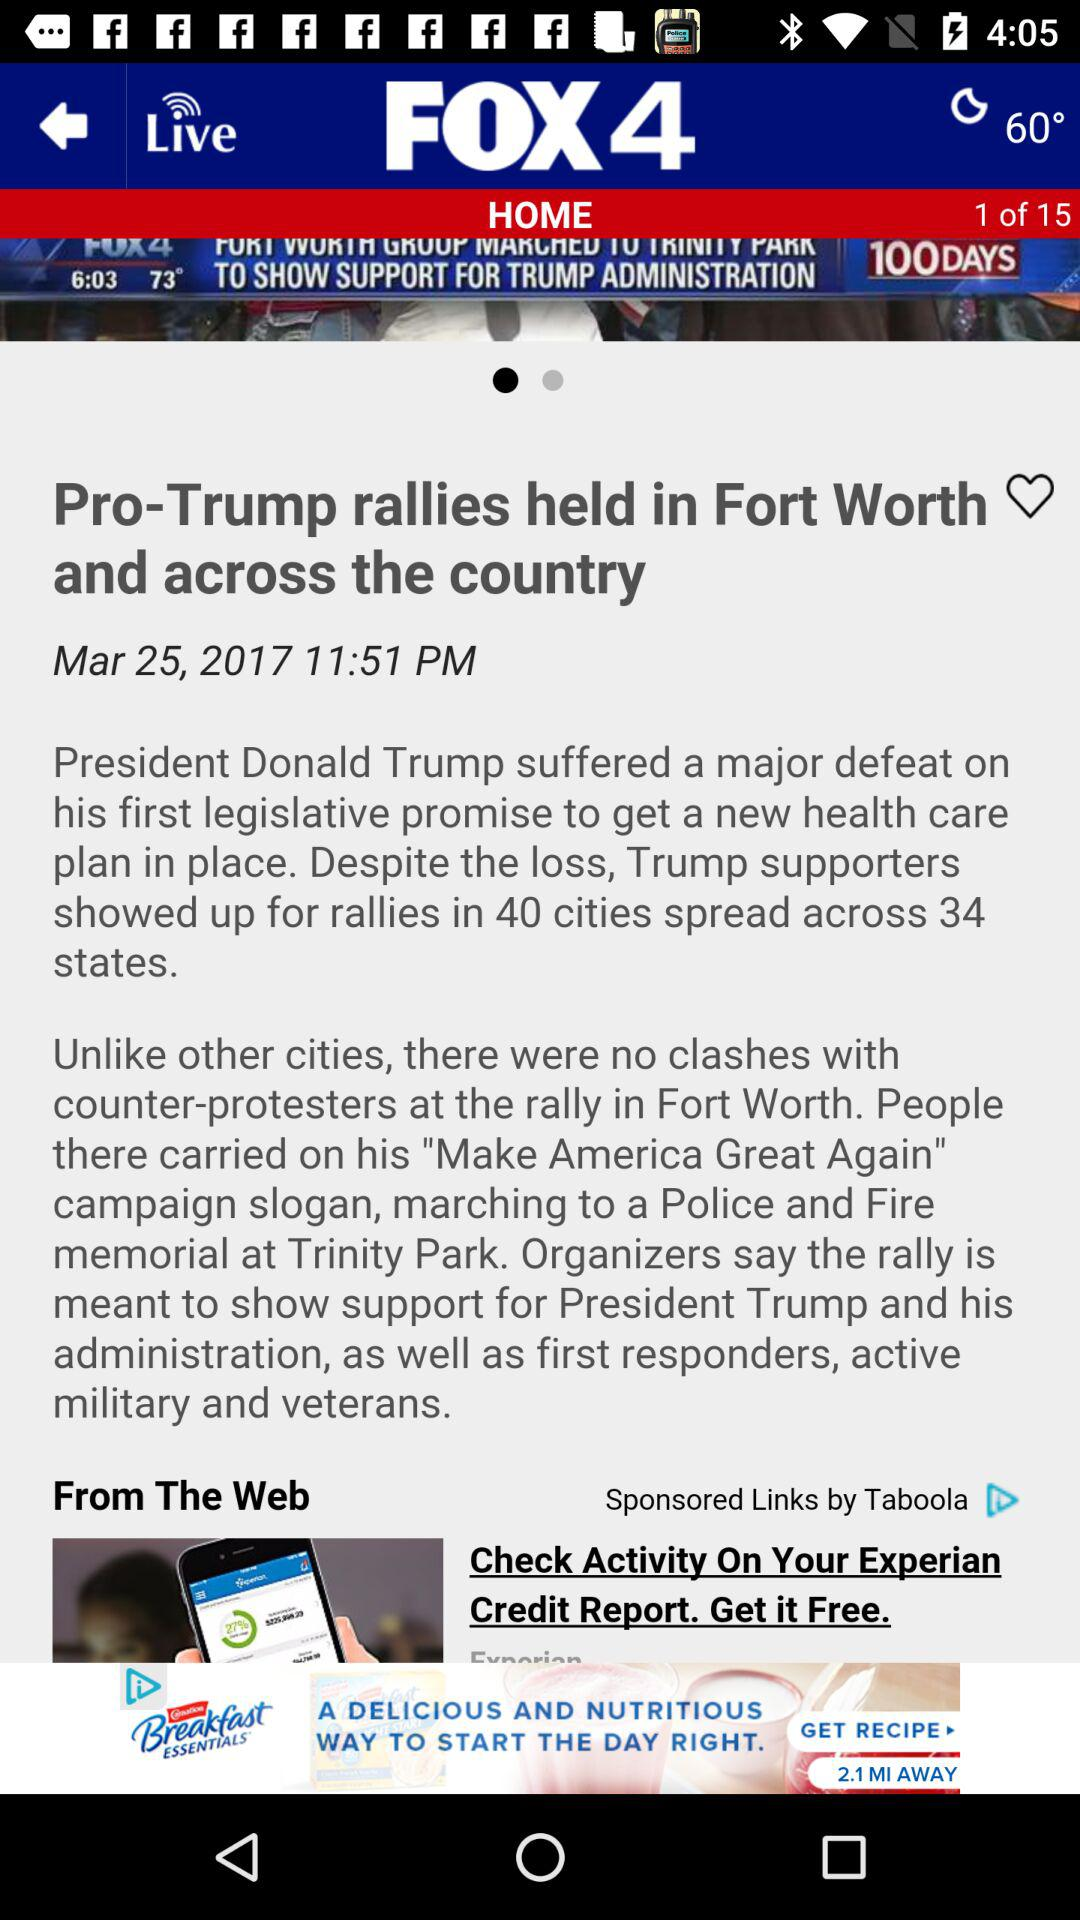What is the article title? The article title is "Pro-Trump rallies held in Fort Worth and across the country". 